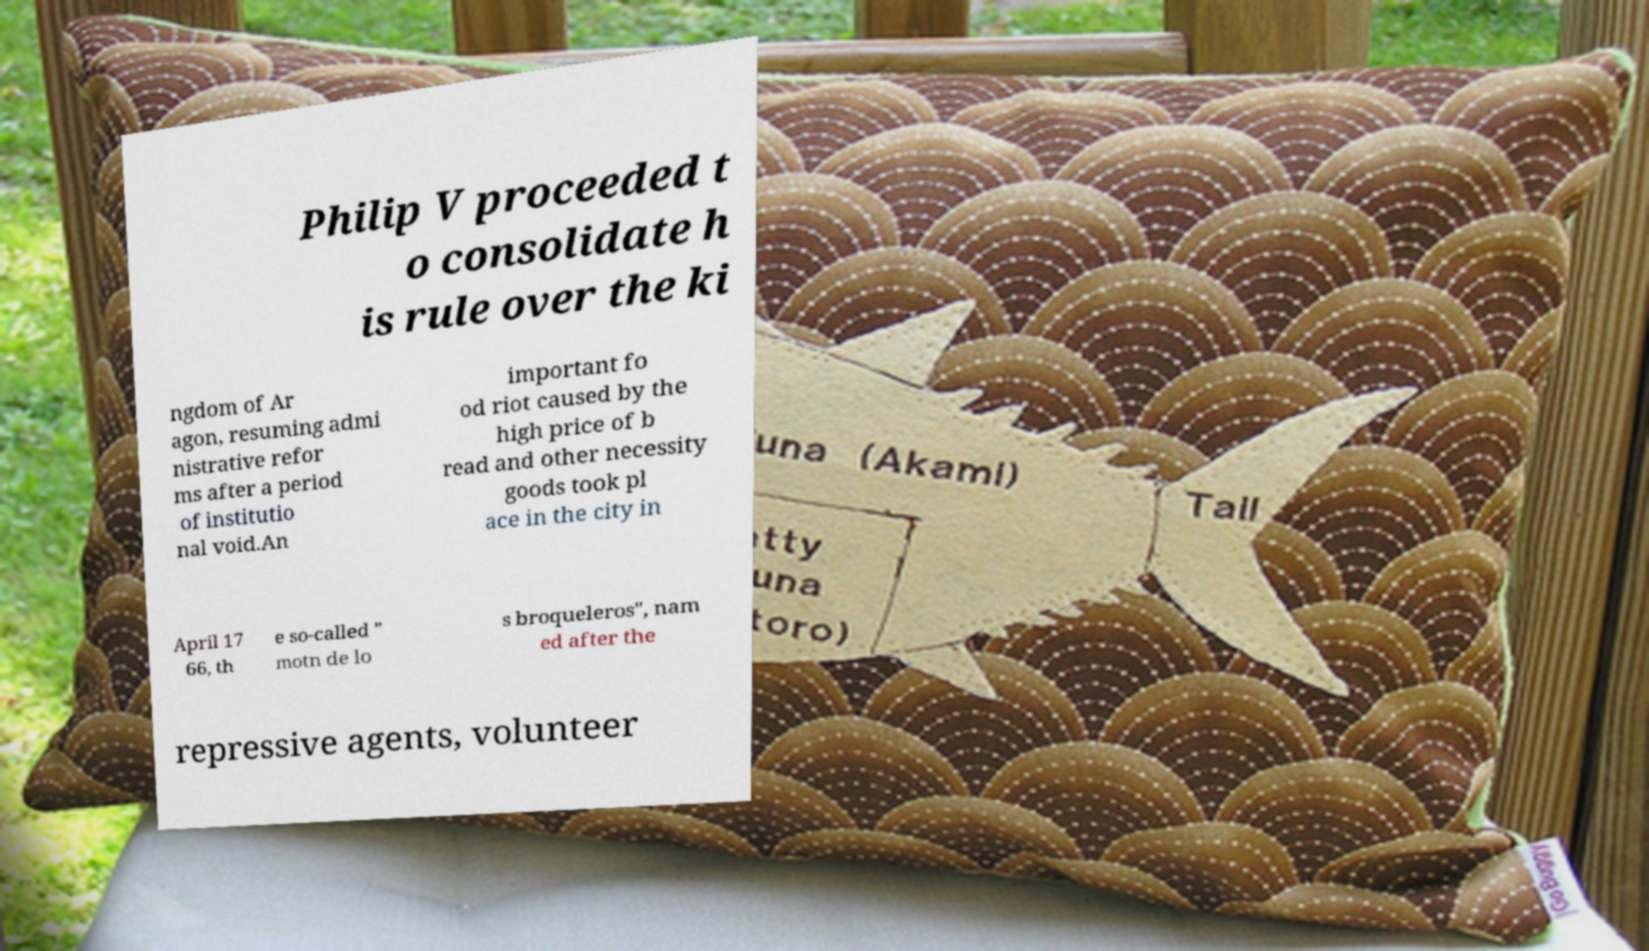Can you accurately transcribe the text from the provided image for me? Philip V proceeded t o consolidate h is rule over the ki ngdom of Ar agon, resuming admi nistrative refor ms after a period of institutio nal void.An important fo od riot caused by the high price of b read and other necessity goods took pl ace in the city in April 17 66, th e so-called " motn de lo s broqueleros", nam ed after the repressive agents, volunteer 